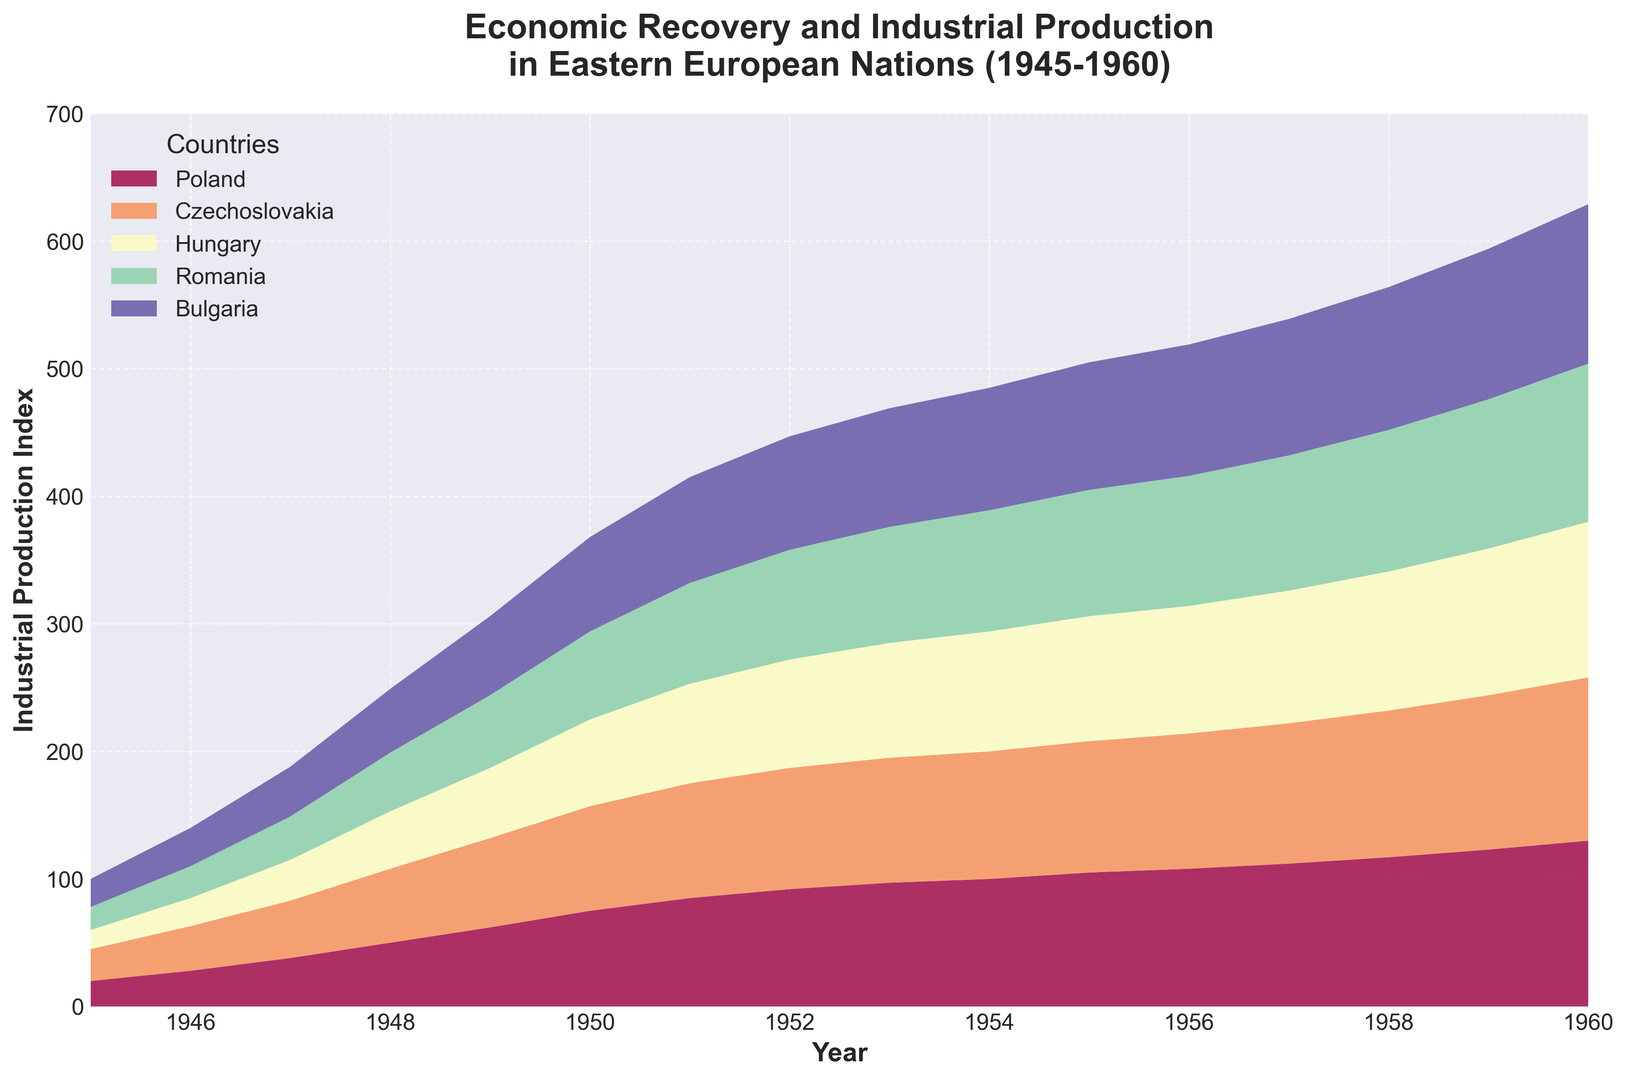Which country had the highest industrial production in 1950? We look at the value for each country in 1950 and find that Czechoslovakia, with an industrial production index of 82, had the highest value.
Answer: Czechoslovakia Which country showed the most significant increase in industrial production from 1945 to 1960? Calculate the difference between 1960 and 1945 values for all countries: Poland (130-20=110), Czechoslovakia (128-25=103), Hungary (122-15=107), Romania (124-18=106), Bulgaria (125-22=103). Poland had the most significant increase with a difference of 110.
Answer: Poland By how much did Hungary's industrial production index increase between 1956 and 1958? Subtract the 1956 value from the 1958 value for Hungary: 109 (1958) - 100 (1956) = 9.
Answer: 9 In which year did Bulgaria’s industrial production index first surpass 100? Identify the year when Bulgaria’s value first exceeds 100. The index surpasses 100 in the year 1955 with a value of 100.
Answer: 1955 Which country had the smallest increase in industrial production between 1945 and 1950? The difference in industrial production from 1945 to 1950 for each country is: Poland (75-20=55), Czechoslovakia (82-25=57), Hungary (68-15=53), Romania (69-18=51), Bulgaria (74-22=52). Romania had the smallest increase with a difference of 51.
Answer: Romania How many years did it take for Poland’s industrial production to double since 1945? Find the first year that has at least twice the value of Poland’s 1945 industrial production (20). In 1949, Poland’s production reaches 62, which is more than double of 20.
Answer: 1949 (4 years) Compare the industrial production index of Romania and Bulgaria in 1957. Which country had a higher index? The industrial production index for Romania in 1957 was 106, and for Bulgaria, it was 107. Thus, Bulgaria had a slightly higher index.
Answer: Bulgaria What is the difference in industrial production index between Romania and Hungary in 1960? Subtract Hungary’s value from Romania’s value in 1960: 124 (Romania) - 122 (Hungary) = 2.
Answer: 2 By 1960, which country reached the 120 industrial production index first? Check the year in which each country's industrial production index first exceeds 120. Poland and Hungary reach it in 1960, whereas Czechoslovakia achieves in 1959, making Czechoslovakia the first.
Answer: Czechoslovakia 